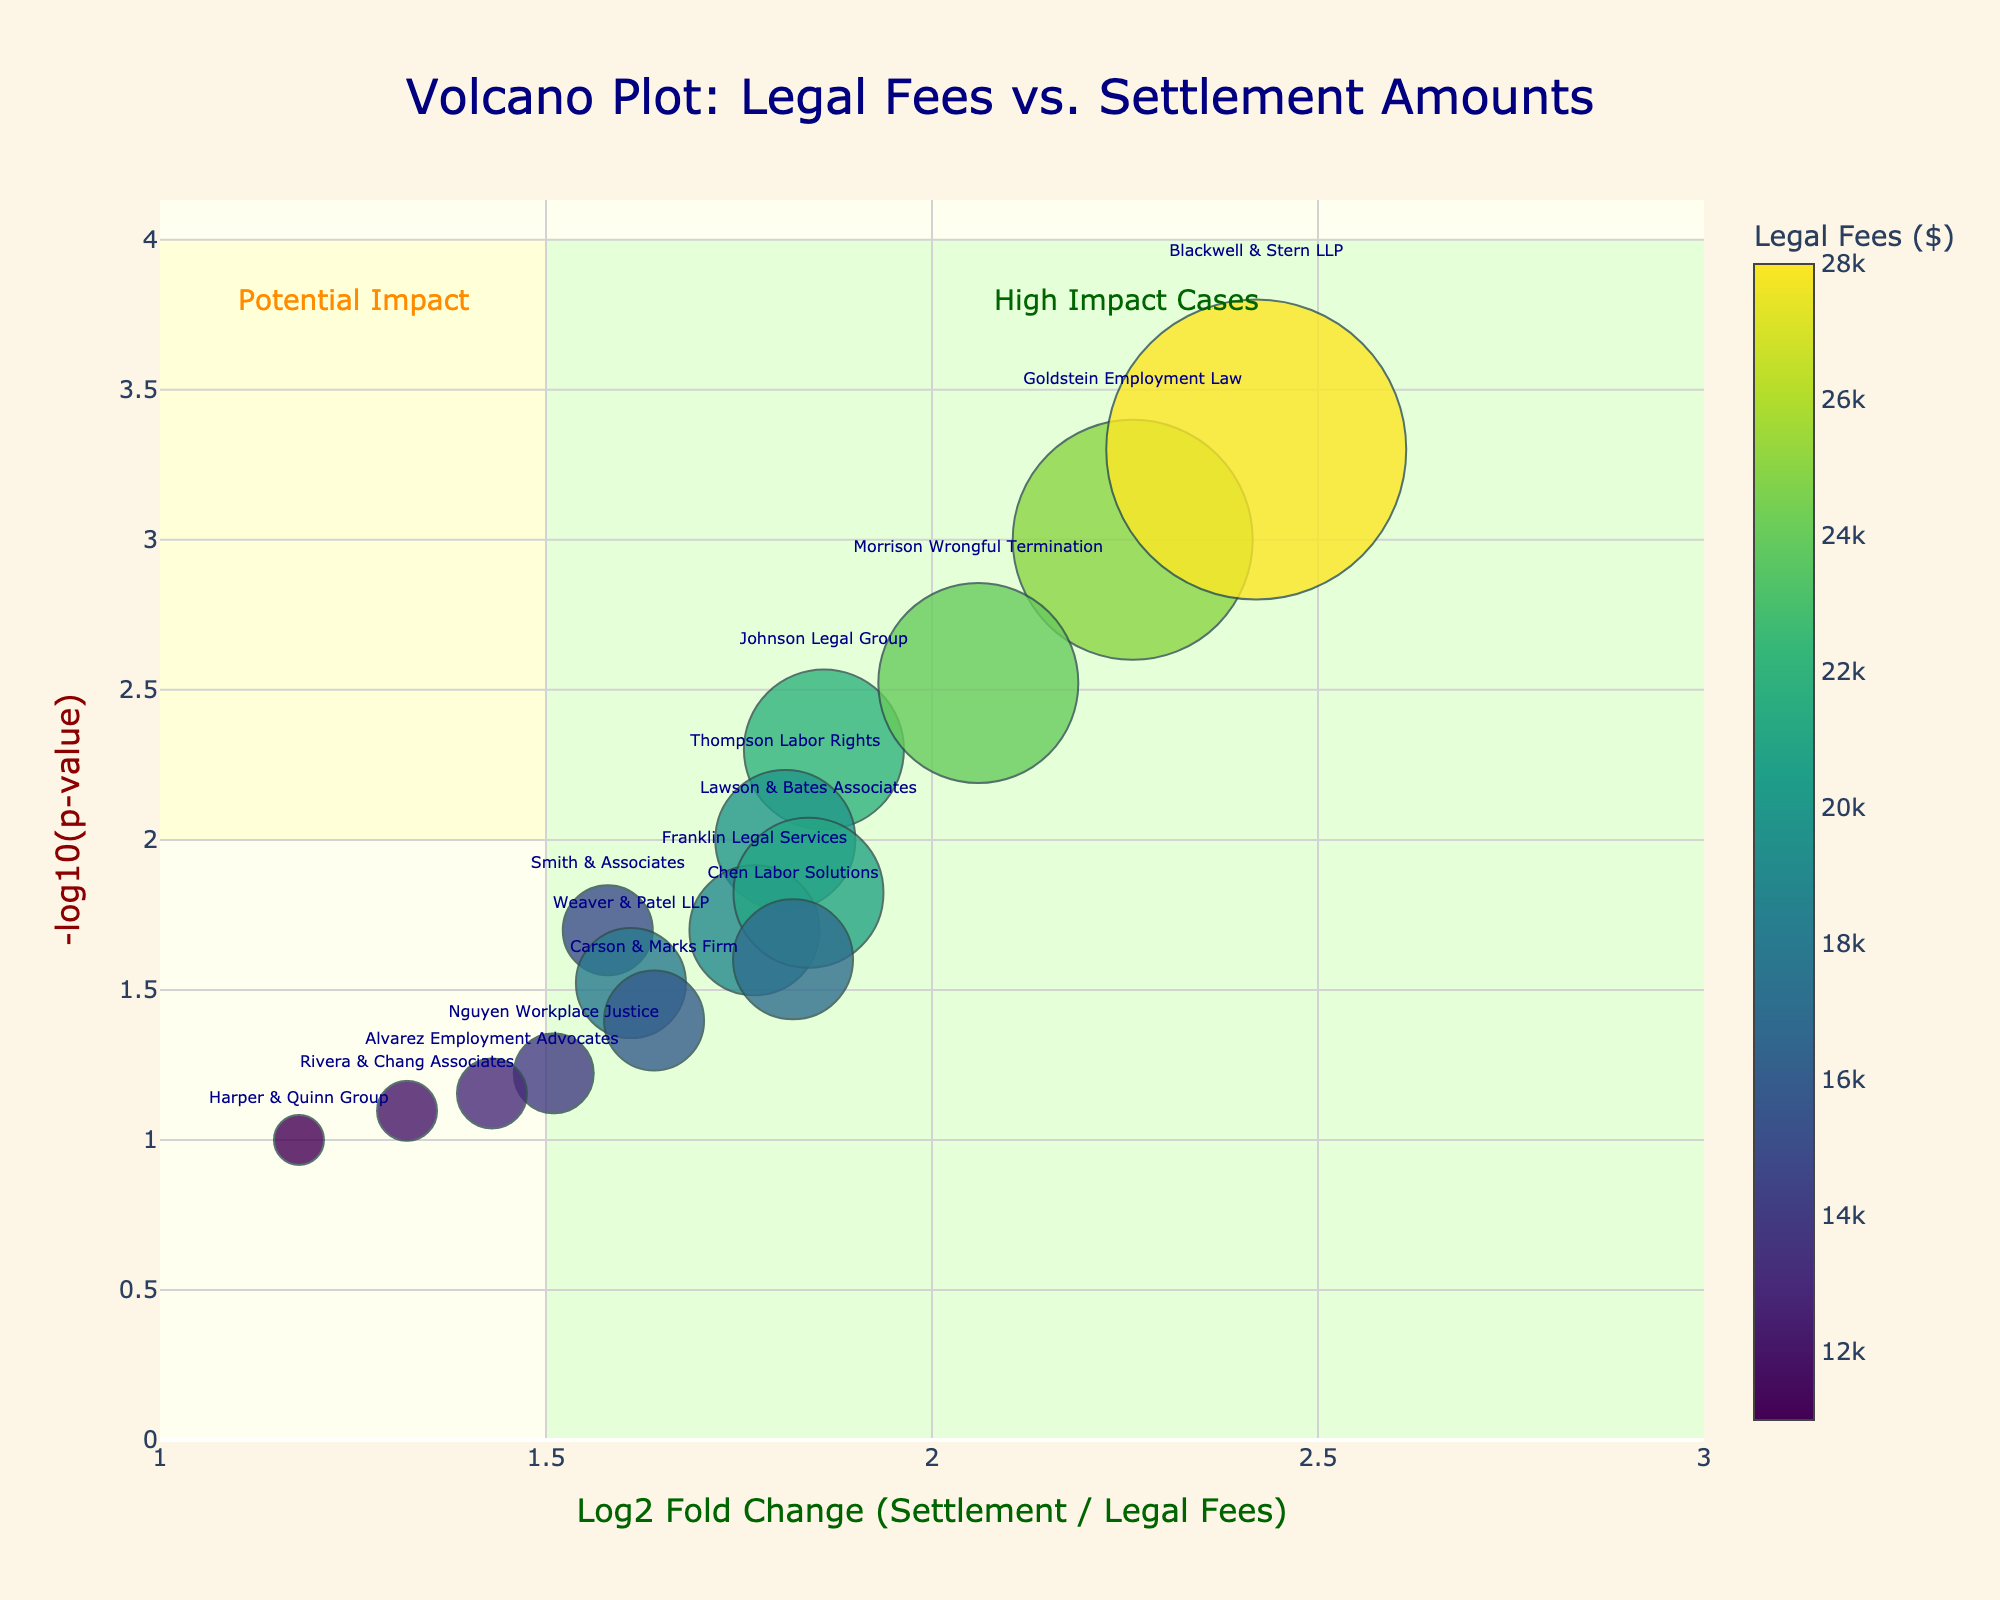How many data points are shown on the plot? Count the number of markers on the plot. Each marker represents a data point corresponding to a legal firm.
Answer: 15 What is the title of the plot? The title is usually displayed at the top center of the plot in a larger font.
Answer: Volcano Plot: Legal Fees vs. Settlement Amounts Which legal firm has the highest -log10(p-value)? Look for the data point that is vertically the highest on the y-axis, since -log10(p-value) is plotted on the y-axis.
Answer: Blackwell & Stern LLP What are the x and y-axis labels on the plot? Axis labels are typically shown below the x-axis and to the left of the y-axis.
Answer: Log2 Fold Change (Settlement / Legal Fees), -log10(p-value) Which firms are labeled as "High Impact Cases"? Firms in the shaded region labeled as "High Impact Cases" should be identified.
Answer: Goldstein Employment Law, Blackwell & Stern LLP, Morrison Wrongful Termination How does the marker size relate to the data? The marker size corresponds to the settlement amount, as indicated in the hover information or legend.
Answer: Settlement amount Which legal firm has the smallest legal fees? The color of the markers represents legal fees; the firm with the darkest marker has the smallest fees.
Answer: Harper & Quinn Group Are there any legal firms with a Log2 Fold Change between 1.5 and 1.8 and a -log10(p-value) greater than 2? If so, which ones? Look for data points in the specific range of the x-axis (1.5 to 1.8) and with y-axis values greater than 2.
Answer: Thompson Labor Rights, Johnson Legal Group, Lawson & Bates Associates, Franklin Legal Services, Chen Labor Solutions What is the range of legal fees displayed on the plot? The color bar on the right side of the plot indicates the range of legal fees.
Answer: $11,000 to $28,000 Compare the settlement amounts for "Smith & Associates" and "Franklin Legal Services." Which is higher? Hover over or locate the markers associated with "Smith & Associates" and "Franklin Legal Services" on the plot and compare their sizes.
Answer: Franklin Legal Services 